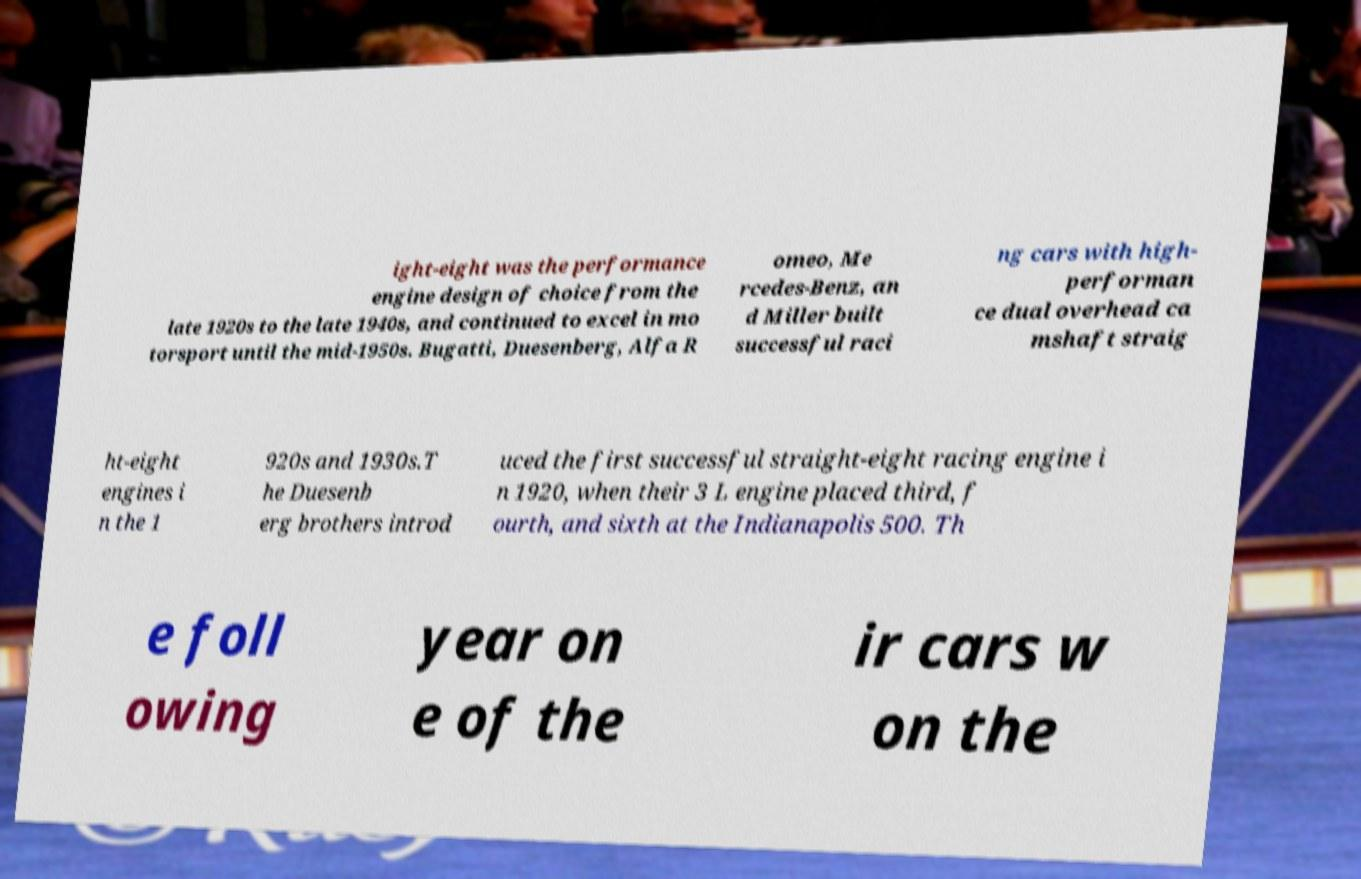Could you extract and type out the text from this image? ight-eight was the performance engine design of choice from the late 1920s to the late 1940s, and continued to excel in mo torsport until the mid-1950s. Bugatti, Duesenberg, Alfa R omeo, Me rcedes-Benz, an d Miller built successful raci ng cars with high- performan ce dual overhead ca mshaft straig ht-eight engines i n the 1 920s and 1930s.T he Duesenb erg brothers introd uced the first successful straight-eight racing engine i n 1920, when their 3 L engine placed third, f ourth, and sixth at the Indianapolis 500. Th e foll owing year on e of the ir cars w on the 